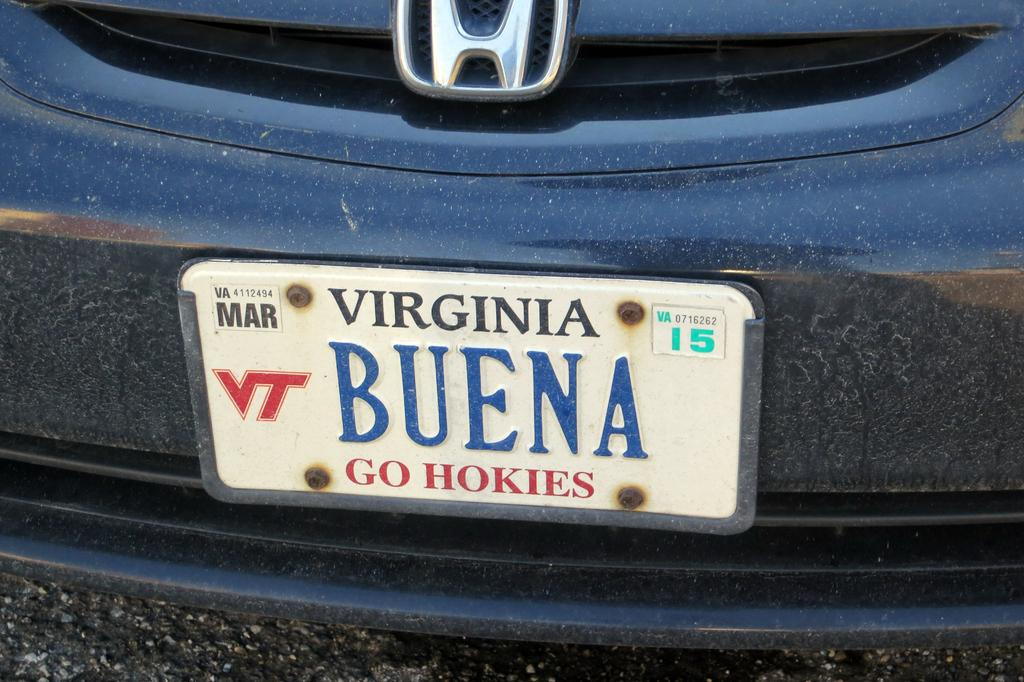Provide a one-sentence caption for the provided image. A Buena sign on the back of a car. 